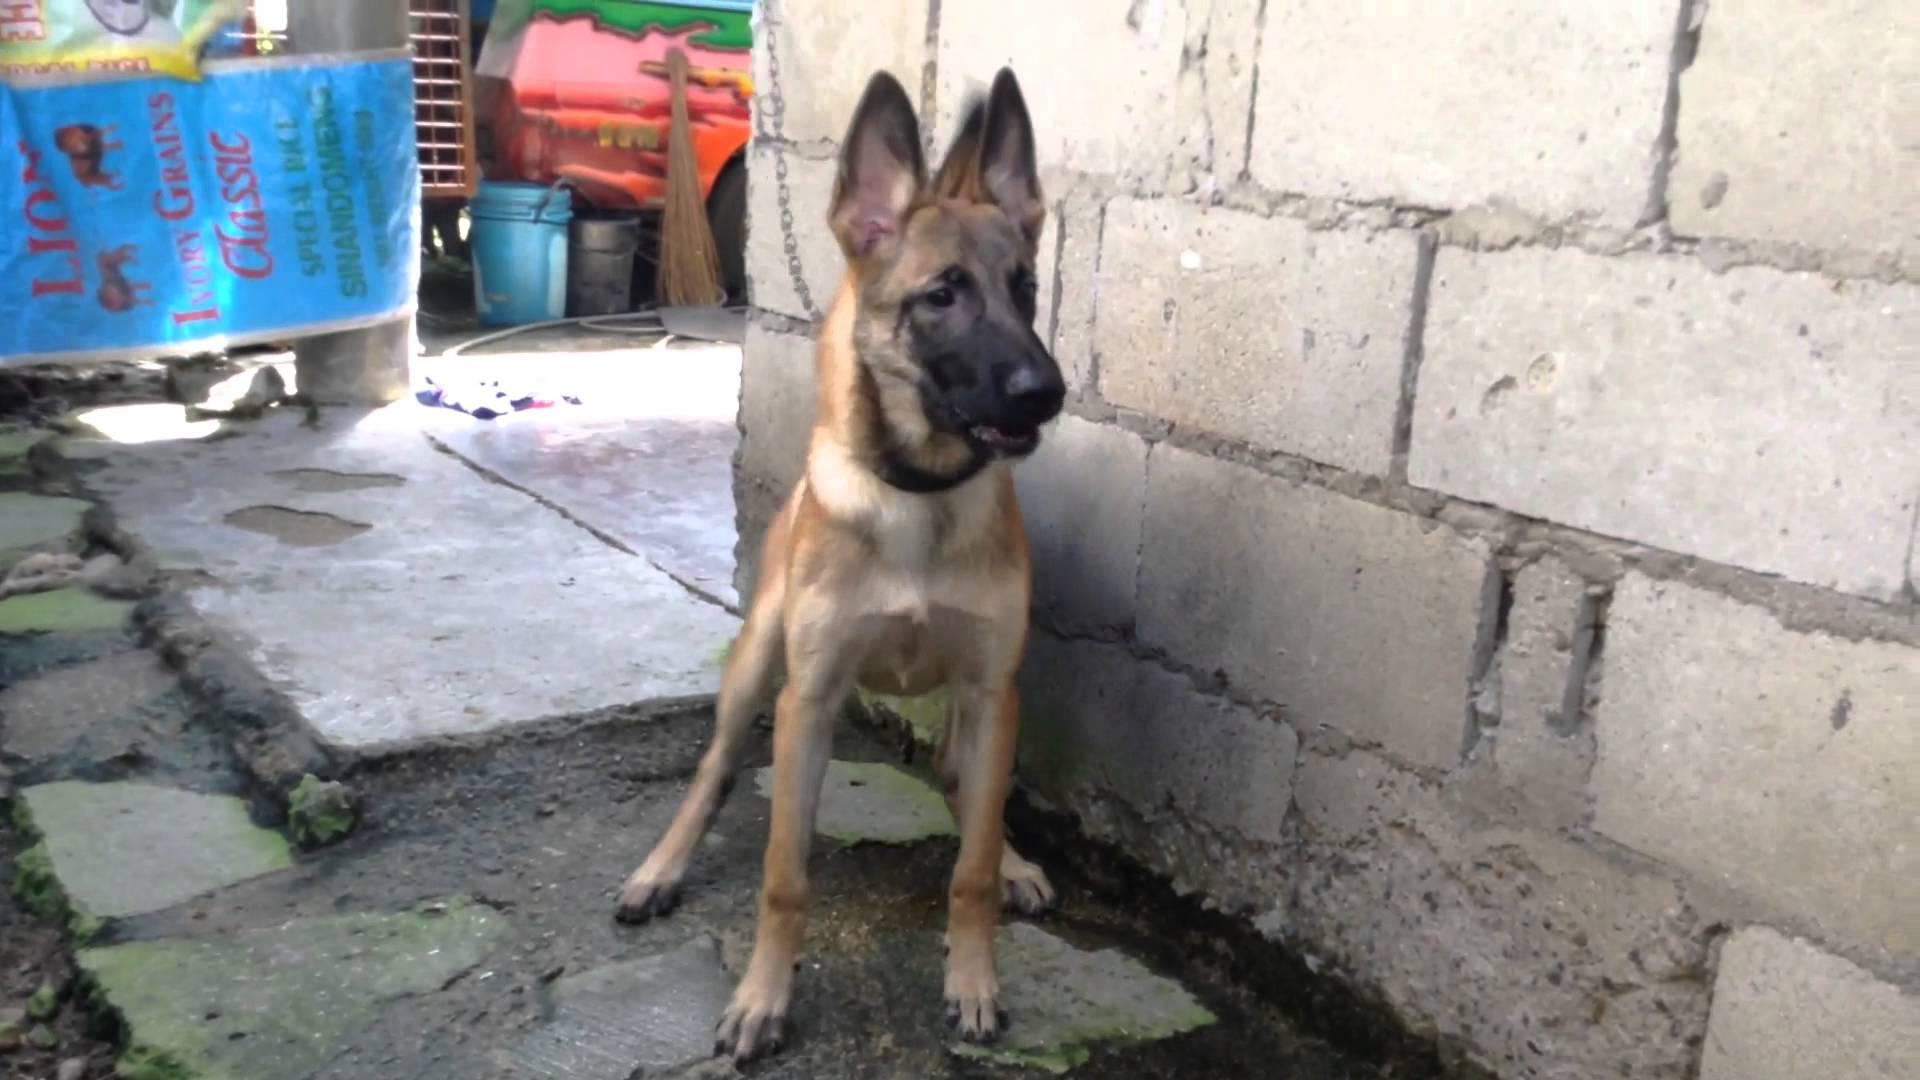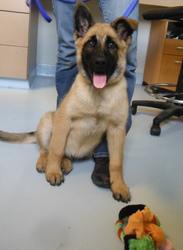The first image is the image on the left, the second image is the image on the right. Given the left and right images, does the statement "In one of the images, the dog is on a tile floor." hold true? Answer yes or no. No. The first image is the image on the left, the second image is the image on the right. Examine the images to the left and right. Is the description "Each image contains one german shepherd, and the right image shows a dog moving toward the lower left." accurate? Answer yes or no. No. 